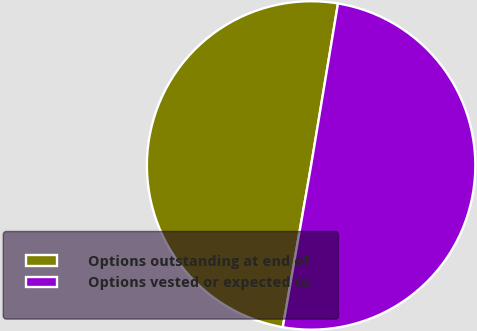<chart> <loc_0><loc_0><loc_500><loc_500><pie_chart><fcel>Options outstanding at end of<fcel>Options vested or expected to<nl><fcel>49.86%<fcel>50.14%<nl></chart> 